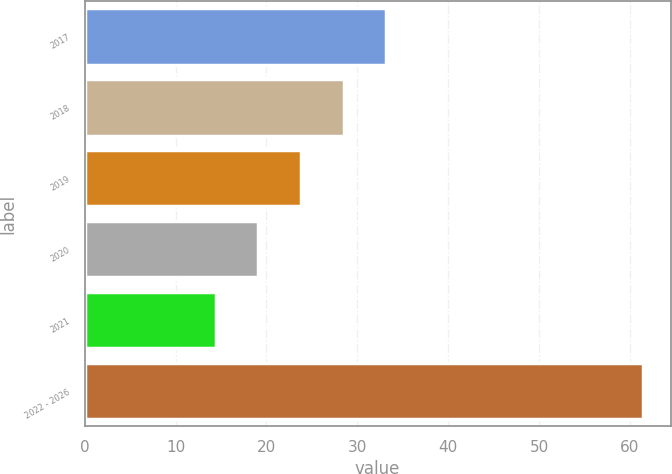<chart> <loc_0><loc_0><loc_500><loc_500><bar_chart><fcel>2017<fcel>2018<fcel>2019<fcel>2020<fcel>2021<fcel>2022 - 2026<nl><fcel>33.2<fcel>28.5<fcel>23.8<fcel>19.1<fcel>14.4<fcel>61.4<nl></chart> 